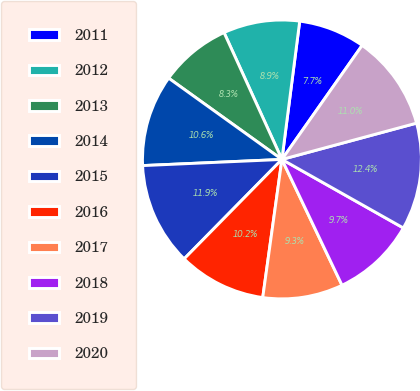Convert chart. <chart><loc_0><loc_0><loc_500><loc_500><pie_chart><fcel>2011<fcel>2012<fcel>2013<fcel>2014<fcel>2015<fcel>2016<fcel>2017<fcel>2018<fcel>2019<fcel>2020<nl><fcel>7.72%<fcel>8.85%<fcel>8.28%<fcel>10.61%<fcel>11.93%<fcel>10.17%<fcel>9.29%<fcel>9.73%<fcel>12.37%<fcel>11.05%<nl></chart> 